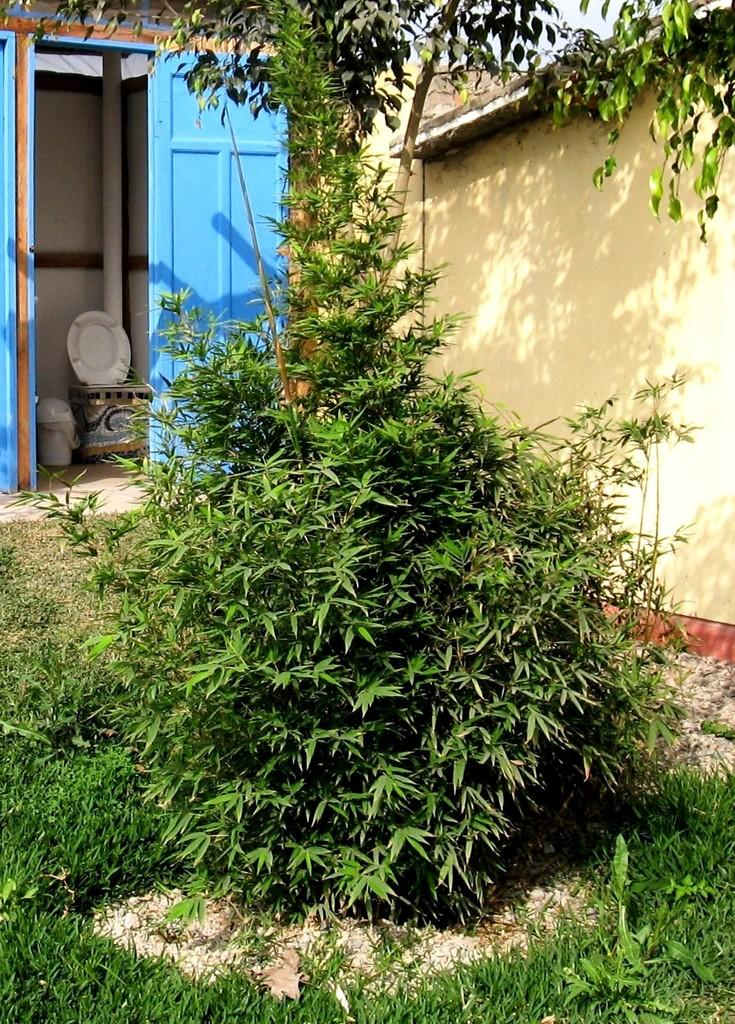What type of surface can be seen at the bottom of the image? There is ground visible in the image. What type of vegetation is present in the image? There are plants and a tree in the image. What type of structure is visible in the image? There are walls in the image. What type of infrastructure is present in the image? A pipeline is present in the image. What type of fixture is visible in the image? There is a toilet seat in the image. What type of container is visible in the image? A bin is visible in the image. What type of entrance is visible in the image? There is a door in the image. What part of the natural environment is visible in the image? The sky is visible in the image. What type of maid is visible in the image? There is no maid present in the image. How does the nation appear in the image? The image does not depict a nation; it shows a ground, plants, walls, a tree, a pipeline, a toilet seat, a bin, a door, and the sky. 